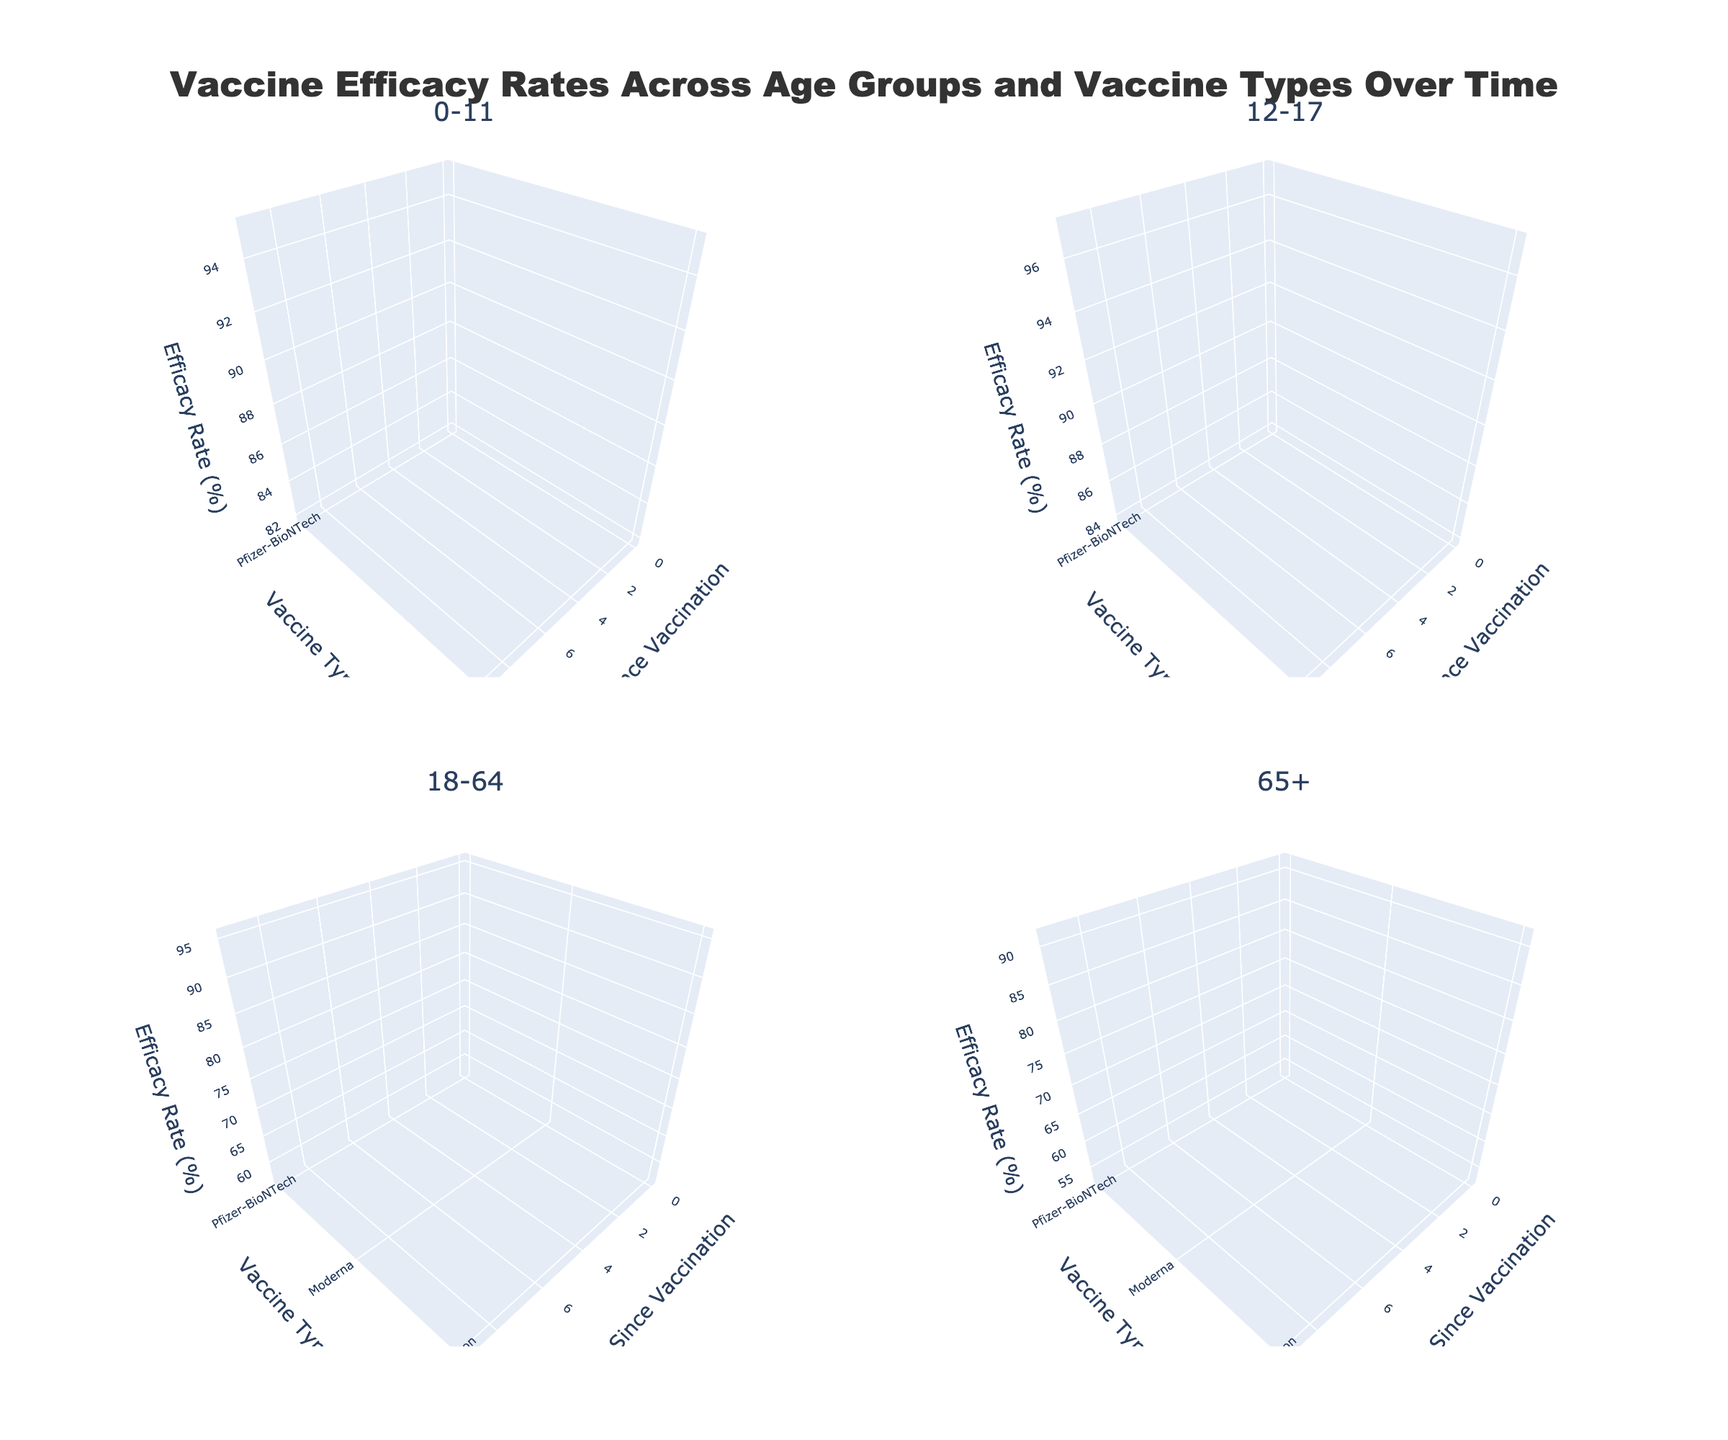What is the title of the plot? The title can be found at the top of the plot, centered and in a larger font size compared to other text elements.
Answer: Vaccine Efficacy Rates Across Age Groups and Vaccine Types Over Time Which age group shows the highest initial efficacy rate for Moderna? By examining the efficacy rates at 0 months for each age group, we can see which group has the highest value for Moderna. The highest initial efficacy rate for Moderna among age groups is 96% for 12-17.
Answer: 12-17 How does the efficacy rate of Pfizer-BioNTech change over 9 months for the age group 18-64? We observe the efficacy rate for Pfizer-BioNTech at different time points for the age group 18-64. At 0 months, the efficacy rate is 95%, and it decreases to 80% at 9 months.
Answer: It decreases by 15% Which vaccine shows the least decline in efficacy for the age group 0-11 over 9 months? Reviewing the efficacy rates for the age group 0-11, both Pfizer-BioNTech and Moderna show a decline. Pfizer-BioNTech decreases from 95% to 83% (12% decline), and Moderna decreases from 94% to 82% (12% decline). Both vaccines show the same decline.
Answer: Pfizer-BioNTech and Moderna Which age group has the lowest efficacy rate for Johnson & Johnson at 3 months? Observing the efficacy rates specifically for Johnson & Johnson at the 3-month point, the age group 65+ shows the lowest efficacy rate at 64%.
Answer: 65+ What is the average efficacy rate of Moderna across all age groups at 6 months? To find the average, we sum the efficacy rates for Moderna at the 6-month mark across all age groups (87 + 89 + 85 + 81) and divide by the number of age groups, which is 4. The sum is 342, so the average is 342/4.
Answer: 85.5% How do the efficacy rates for Pfizer-BioNTech in the 0-11 age group compare to the 12-17 age group at 6 months? Comparing the efficacy rates at the 6-month mark, Pfizer-BioNTech shows 88% efficacy for 0-11 and 90% for 12-17. The 12-17 age group has a 2% higher efficacy.
Answer: 2% higher for 12-17 Which vaccine has the fastest decline in efficacy rate for the age group 65+ over 9 months? By comparing the starting point (0 months) and the final value (9 months) for each vaccine in the age group 65+, we see the declines: Pfizer-BioNTech (91% to 76%, 15%), Moderna (90% to 75%, 15%), and Johnson & Johnson (68% to 53%, 15%). All show the same decline.
Answer: All have the same decline How does the efficacy rate of Johnson & Johnson for the 65+ age group compare to Moderna for the same group at 3 months? At 3 months, the efficacy rate for the 65+ age group is 64% for Johnson & Johnson and 86% for Moderna. Moderna's efficacy rate is 22% higher than Johnson & Johnson’s.
Answer: 22% higher for Moderna 